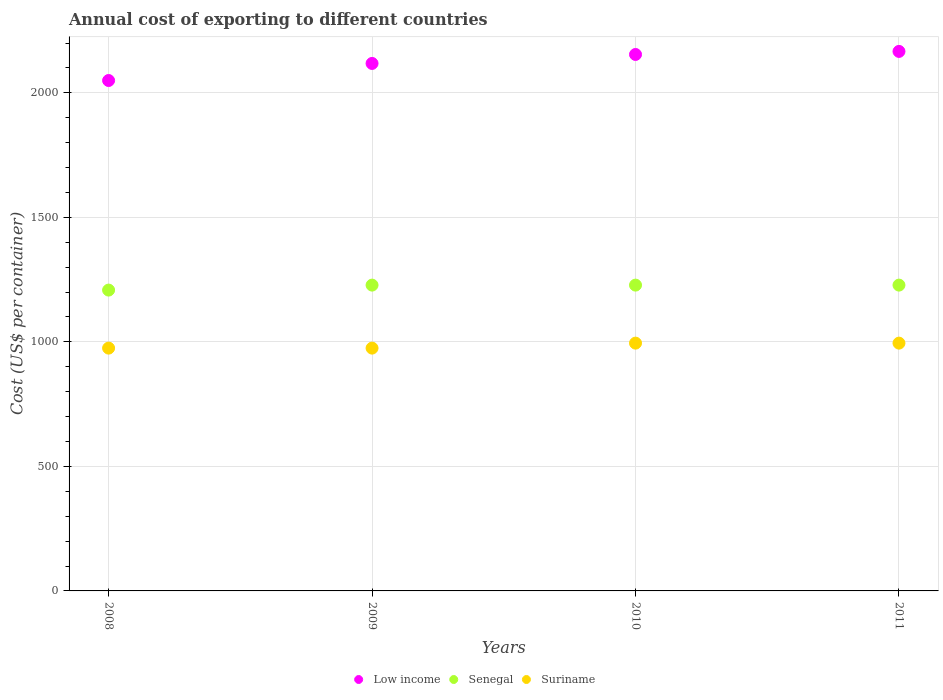Is the number of dotlines equal to the number of legend labels?
Your response must be concise. Yes. What is the total annual cost of exporting in Low income in 2011?
Offer a very short reply. 2166.43. Across all years, what is the maximum total annual cost of exporting in Low income?
Provide a short and direct response. 2166.43. Across all years, what is the minimum total annual cost of exporting in Senegal?
Your answer should be compact. 1208. What is the total total annual cost of exporting in Senegal in the graph?
Provide a short and direct response. 4892. What is the difference between the total annual cost of exporting in Low income in 2010 and that in 2011?
Ensure brevity in your answer.  -12.29. What is the difference between the total annual cost of exporting in Low income in 2010 and the total annual cost of exporting in Senegal in 2008?
Give a very brief answer. 946.14. What is the average total annual cost of exporting in Suriname per year?
Make the answer very short. 985. In the year 2009, what is the difference between the total annual cost of exporting in Low income and total annual cost of exporting in Senegal?
Offer a very short reply. 890.11. What is the ratio of the total annual cost of exporting in Senegal in 2008 to that in 2011?
Your answer should be compact. 0.98. What is the difference between the highest and the second highest total annual cost of exporting in Senegal?
Your answer should be very brief. 0. What is the difference between the highest and the lowest total annual cost of exporting in Low income?
Offer a terse response. 116.86. Does the total annual cost of exporting in Suriname monotonically increase over the years?
Provide a short and direct response. No. Is the total annual cost of exporting in Low income strictly greater than the total annual cost of exporting in Senegal over the years?
Provide a succinct answer. Yes. How many dotlines are there?
Ensure brevity in your answer.  3. How many years are there in the graph?
Give a very brief answer. 4. Are the values on the major ticks of Y-axis written in scientific E-notation?
Offer a terse response. No. Does the graph contain any zero values?
Provide a short and direct response. No. How are the legend labels stacked?
Your response must be concise. Horizontal. What is the title of the graph?
Your answer should be very brief. Annual cost of exporting to different countries. Does "Guyana" appear as one of the legend labels in the graph?
Keep it short and to the point. No. What is the label or title of the Y-axis?
Offer a terse response. Cost (US$ per container). What is the Cost (US$ per container) in Low income in 2008?
Offer a very short reply. 2049.57. What is the Cost (US$ per container) of Senegal in 2008?
Your response must be concise. 1208. What is the Cost (US$ per container) of Suriname in 2008?
Offer a very short reply. 975. What is the Cost (US$ per container) in Low income in 2009?
Your answer should be very brief. 2118.11. What is the Cost (US$ per container) in Senegal in 2009?
Keep it short and to the point. 1228. What is the Cost (US$ per container) in Suriname in 2009?
Offer a terse response. 975. What is the Cost (US$ per container) of Low income in 2010?
Offer a terse response. 2154.14. What is the Cost (US$ per container) in Senegal in 2010?
Ensure brevity in your answer.  1228. What is the Cost (US$ per container) of Suriname in 2010?
Ensure brevity in your answer.  995. What is the Cost (US$ per container) of Low income in 2011?
Keep it short and to the point. 2166.43. What is the Cost (US$ per container) in Senegal in 2011?
Keep it short and to the point. 1228. What is the Cost (US$ per container) in Suriname in 2011?
Offer a terse response. 995. Across all years, what is the maximum Cost (US$ per container) of Low income?
Provide a short and direct response. 2166.43. Across all years, what is the maximum Cost (US$ per container) of Senegal?
Give a very brief answer. 1228. Across all years, what is the maximum Cost (US$ per container) of Suriname?
Offer a terse response. 995. Across all years, what is the minimum Cost (US$ per container) of Low income?
Ensure brevity in your answer.  2049.57. Across all years, what is the minimum Cost (US$ per container) of Senegal?
Make the answer very short. 1208. Across all years, what is the minimum Cost (US$ per container) in Suriname?
Ensure brevity in your answer.  975. What is the total Cost (US$ per container) of Low income in the graph?
Keep it short and to the point. 8488.25. What is the total Cost (US$ per container) of Senegal in the graph?
Ensure brevity in your answer.  4892. What is the total Cost (US$ per container) of Suriname in the graph?
Provide a short and direct response. 3940. What is the difference between the Cost (US$ per container) in Low income in 2008 and that in 2009?
Give a very brief answer. -68.54. What is the difference between the Cost (US$ per container) in Suriname in 2008 and that in 2009?
Your answer should be very brief. 0. What is the difference between the Cost (US$ per container) in Low income in 2008 and that in 2010?
Offer a very short reply. -104.57. What is the difference between the Cost (US$ per container) in Senegal in 2008 and that in 2010?
Your response must be concise. -20. What is the difference between the Cost (US$ per container) of Low income in 2008 and that in 2011?
Keep it short and to the point. -116.86. What is the difference between the Cost (US$ per container) in Low income in 2009 and that in 2010?
Offer a very short reply. -36.04. What is the difference between the Cost (US$ per container) in Low income in 2009 and that in 2011?
Provide a short and direct response. -48.32. What is the difference between the Cost (US$ per container) in Suriname in 2009 and that in 2011?
Your answer should be compact. -20. What is the difference between the Cost (US$ per container) of Low income in 2010 and that in 2011?
Ensure brevity in your answer.  -12.29. What is the difference between the Cost (US$ per container) in Suriname in 2010 and that in 2011?
Give a very brief answer. 0. What is the difference between the Cost (US$ per container) in Low income in 2008 and the Cost (US$ per container) in Senegal in 2009?
Your response must be concise. 821.57. What is the difference between the Cost (US$ per container) of Low income in 2008 and the Cost (US$ per container) of Suriname in 2009?
Offer a terse response. 1074.57. What is the difference between the Cost (US$ per container) of Senegal in 2008 and the Cost (US$ per container) of Suriname in 2009?
Keep it short and to the point. 233. What is the difference between the Cost (US$ per container) in Low income in 2008 and the Cost (US$ per container) in Senegal in 2010?
Make the answer very short. 821.57. What is the difference between the Cost (US$ per container) of Low income in 2008 and the Cost (US$ per container) of Suriname in 2010?
Your answer should be compact. 1054.57. What is the difference between the Cost (US$ per container) of Senegal in 2008 and the Cost (US$ per container) of Suriname in 2010?
Provide a short and direct response. 213. What is the difference between the Cost (US$ per container) of Low income in 2008 and the Cost (US$ per container) of Senegal in 2011?
Your response must be concise. 821.57. What is the difference between the Cost (US$ per container) of Low income in 2008 and the Cost (US$ per container) of Suriname in 2011?
Provide a short and direct response. 1054.57. What is the difference between the Cost (US$ per container) in Senegal in 2008 and the Cost (US$ per container) in Suriname in 2011?
Offer a very short reply. 213. What is the difference between the Cost (US$ per container) in Low income in 2009 and the Cost (US$ per container) in Senegal in 2010?
Provide a short and direct response. 890.11. What is the difference between the Cost (US$ per container) in Low income in 2009 and the Cost (US$ per container) in Suriname in 2010?
Your response must be concise. 1123.11. What is the difference between the Cost (US$ per container) of Senegal in 2009 and the Cost (US$ per container) of Suriname in 2010?
Provide a short and direct response. 233. What is the difference between the Cost (US$ per container) in Low income in 2009 and the Cost (US$ per container) in Senegal in 2011?
Offer a very short reply. 890.11. What is the difference between the Cost (US$ per container) in Low income in 2009 and the Cost (US$ per container) in Suriname in 2011?
Provide a succinct answer. 1123.11. What is the difference between the Cost (US$ per container) of Senegal in 2009 and the Cost (US$ per container) of Suriname in 2011?
Ensure brevity in your answer.  233. What is the difference between the Cost (US$ per container) of Low income in 2010 and the Cost (US$ per container) of Senegal in 2011?
Make the answer very short. 926.14. What is the difference between the Cost (US$ per container) in Low income in 2010 and the Cost (US$ per container) in Suriname in 2011?
Ensure brevity in your answer.  1159.14. What is the difference between the Cost (US$ per container) in Senegal in 2010 and the Cost (US$ per container) in Suriname in 2011?
Make the answer very short. 233. What is the average Cost (US$ per container) in Low income per year?
Your answer should be compact. 2122.06. What is the average Cost (US$ per container) in Senegal per year?
Offer a very short reply. 1223. What is the average Cost (US$ per container) of Suriname per year?
Provide a short and direct response. 985. In the year 2008, what is the difference between the Cost (US$ per container) of Low income and Cost (US$ per container) of Senegal?
Give a very brief answer. 841.57. In the year 2008, what is the difference between the Cost (US$ per container) of Low income and Cost (US$ per container) of Suriname?
Your answer should be very brief. 1074.57. In the year 2008, what is the difference between the Cost (US$ per container) in Senegal and Cost (US$ per container) in Suriname?
Ensure brevity in your answer.  233. In the year 2009, what is the difference between the Cost (US$ per container) of Low income and Cost (US$ per container) of Senegal?
Provide a short and direct response. 890.11. In the year 2009, what is the difference between the Cost (US$ per container) of Low income and Cost (US$ per container) of Suriname?
Your answer should be compact. 1143.11. In the year 2009, what is the difference between the Cost (US$ per container) of Senegal and Cost (US$ per container) of Suriname?
Your answer should be compact. 253. In the year 2010, what is the difference between the Cost (US$ per container) of Low income and Cost (US$ per container) of Senegal?
Provide a short and direct response. 926.14. In the year 2010, what is the difference between the Cost (US$ per container) of Low income and Cost (US$ per container) of Suriname?
Your response must be concise. 1159.14. In the year 2010, what is the difference between the Cost (US$ per container) in Senegal and Cost (US$ per container) in Suriname?
Provide a short and direct response. 233. In the year 2011, what is the difference between the Cost (US$ per container) of Low income and Cost (US$ per container) of Senegal?
Give a very brief answer. 938.43. In the year 2011, what is the difference between the Cost (US$ per container) of Low income and Cost (US$ per container) of Suriname?
Ensure brevity in your answer.  1171.43. In the year 2011, what is the difference between the Cost (US$ per container) in Senegal and Cost (US$ per container) in Suriname?
Provide a succinct answer. 233. What is the ratio of the Cost (US$ per container) in Low income in 2008 to that in 2009?
Give a very brief answer. 0.97. What is the ratio of the Cost (US$ per container) of Senegal in 2008 to that in 2009?
Your answer should be compact. 0.98. What is the ratio of the Cost (US$ per container) in Suriname in 2008 to that in 2009?
Your response must be concise. 1. What is the ratio of the Cost (US$ per container) of Low income in 2008 to that in 2010?
Offer a terse response. 0.95. What is the ratio of the Cost (US$ per container) of Senegal in 2008 to that in 2010?
Your answer should be compact. 0.98. What is the ratio of the Cost (US$ per container) in Suriname in 2008 to that in 2010?
Your response must be concise. 0.98. What is the ratio of the Cost (US$ per container) in Low income in 2008 to that in 2011?
Give a very brief answer. 0.95. What is the ratio of the Cost (US$ per container) of Senegal in 2008 to that in 2011?
Provide a succinct answer. 0.98. What is the ratio of the Cost (US$ per container) in Suriname in 2008 to that in 2011?
Keep it short and to the point. 0.98. What is the ratio of the Cost (US$ per container) of Low income in 2009 to that in 2010?
Give a very brief answer. 0.98. What is the ratio of the Cost (US$ per container) in Suriname in 2009 to that in 2010?
Keep it short and to the point. 0.98. What is the ratio of the Cost (US$ per container) in Low income in 2009 to that in 2011?
Offer a terse response. 0.98. What is the ratio of the Cost (US$ per container) in Senegal in 2009 to that in 2011?
Give a very brief answer. 1. What is the ratio of the Cost (US$ per container) in Suriname in 2009 to that in 2011?
Give a very brief answer. 0.98. What is the difference between the highest and the second highest Cost (US$ per container) of Low income?
Your answer should be compact. 12.29. What is the difference between the highest and the second highest Cost (US$ per container) in Senegal?
Keep it short and to the point. 0. What is the difference between the highest and the second highest Cost (US$ per container) in Suriname?
Your answer should be very brief. 0. What is the difference between the highest and the lowest Cost (US$ per container) in Low income?
Your answer should be compact. 116.86. What is the difference between the highest and the lowest Cost (US$ per container) of Senegal?
Offer a terse response. 20. 